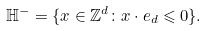Convert formula to latex. <formula><loc_0><loc_0><loc_500><loc_500>\mathbb { H } ^ { - } = \{ x \in \mathbb { Z } ^ { d } \colon x \cdot e _ { d } \leqslant 0 \} .</formula> 